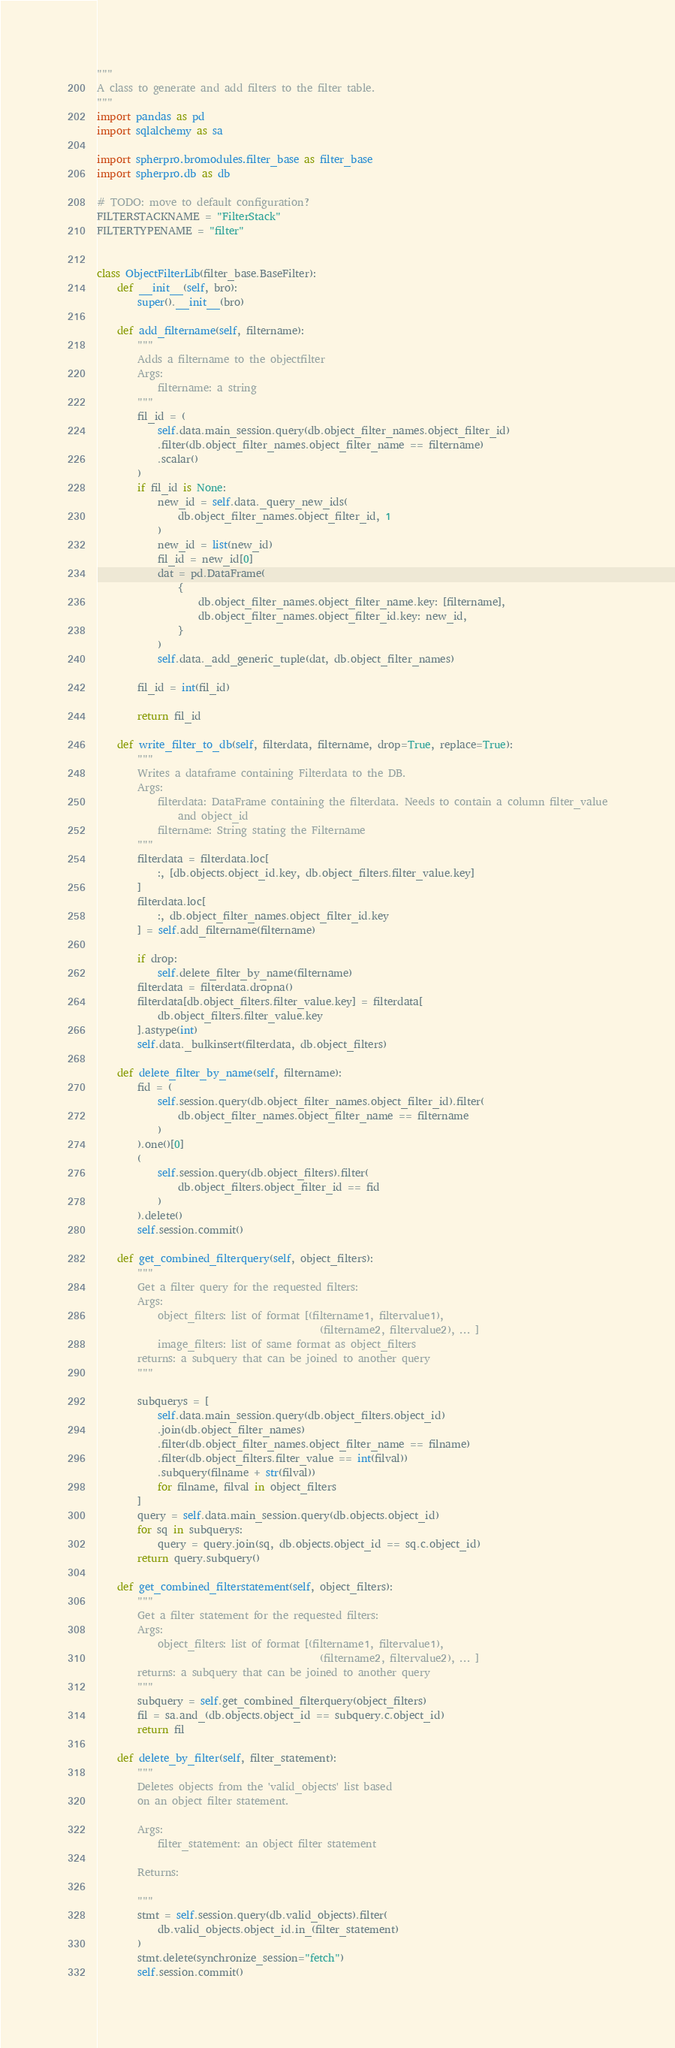Convert code to text. <code><loc_0><loc_0><loc_500><loc_500><_Python_>"""
A class to generate and add filters to the filter table.
"""
import pandas as pd
import sqlalchemy as sa

import spherpro.bromodules.filter_base as filter_base
import spherpro.db as db

# TODO: move to default configuration?
FILTERSTACKNAME = "FilterStack"
FILTERTYPENAME = "filter"


class ObjectFilterLib(filter_base.BaseFilter):
    def __init__(self, bro):
        super().__init__(bro)

    def add_filtername(self, filtername):
        """
        Adds a filtername to the objectfilter
        Args:
            filtername: a string
        """
        fil_id = (
            self.data.main_session.query(db.object_filter_names.object_filter_id)
            .filter(db.object_filter_names.object_filter_name == filtername)
            .scalar()
        )
        if fil_id is None:
            new_id = self.data._query_new_ids(
                db.object_filter_names.object_filter_id, 1
            )
            new_id = list(new_id)
            fil_id = new_id[0]
            dat = pd.DataFrame(
                {
                    db.object_filter_names.object_filter_name.key: [filtername],
                    db.object_filter_names.object_filter_id.key: new_id,
                }
            )
            self.data._add_generic_tuple(dat, db.object_filter_names)

        fil_id = int(fil_id)

        return fil_id

    def write_filter_to_db(self, filterdata, filtername, drop=True, replace=True):
        """
        Writes a dataframe containing Filterdata to the DB.
        Args:
            filterdata: DataFrame containing the filterdata. Needs to contain a column filter_value
                and object_id
            filtername: String stating the Filtername
        """
        filterdata = filterdata.loc[
            :, [db.objects.object_id.key, db.object_filters.filter_value.key]
        ]
        filterdata.loc[
            :, db.object_filter_names.object_filter_id.key
        ] = self.add_filtername(filtername)

        if drop:
            self.delete_filter_by_name(filtername)
        filterdata = filterdata.dropna()
        filterdata[db.object_filters.filter_value.key] = filterdata[
            db.object_filters.filter_value.key
        ].astype(int)
        self.data._bulkinsert(filterdata, db.object_filters)

    def delete_filter_by_name(self, filtername):
        fid = (
            self.session.query(db.object_filter_names.object_filter_id).filter(
                db.object_filter_names.object_filter_name == filtername
            )
        ).one()[0]
        (
            self.session.query(db.object_filters).filter(
                db.object_filters.object_filter_id == fid
            )
        ).delete()
        self.session.commit()

    def get_combined_filterquery(self, object_filters):
        """
        Get a filter query for the requested filters:
        Args:
            object_filters: list of format [(filtername1, filtervalue1),
                                            (filtername2, filtervalue2), ... ]
            image_filters: list of same format as object_filters
        returns: a subquery that can be joined to another query
        """

        subquerys = [
            self.data.main_session.query(db.object_filters.object_id)
            .join(db.object_filter_names)
            .filter(db.object_filter_names.object_filter_name == filname)
            .filter(db.object_filters.filter_value == int(filval))
            .subquery(filname + str(filval))
            for filname, filval in object_filters
        ]
        query = self.data.main_session.query(db.objects.object_id)
        for sq in subquerys:
            query = query.join(sq, db.objects.object_id == sq.c.object_id)
        return query.subquery()

    def get_combined_filterstatement(self, object_filters):
        """
        Get a filter statement for the requested filters:
        Args:
            object_filters: list of format [(filtername1, filtervalue1),
                                            (filtername2, filtervalue2), ... ]
        returns: a subquery that can be joined to another query
        """
        subquery = self.get_combined_filterquery(object_filters)
        fil = sa.and_(db.objects.object_id == subquery.c.object_id)
        return fil

    def delete_by_filter(self, filter_statement):
        """
        Deletes objects from the 'valid_objects' list based
        on an object filter statement.

        Args:
            filter_statement: an object filter statement

        Returns:

        """
        stmt = self.session.query(db.valid_objects).filter(
            db.valid_objects.object_id.in_(filter_statement)
        )
        stmt.delete(synchronize_session="fetch")
        self.session.commit()
</code> 